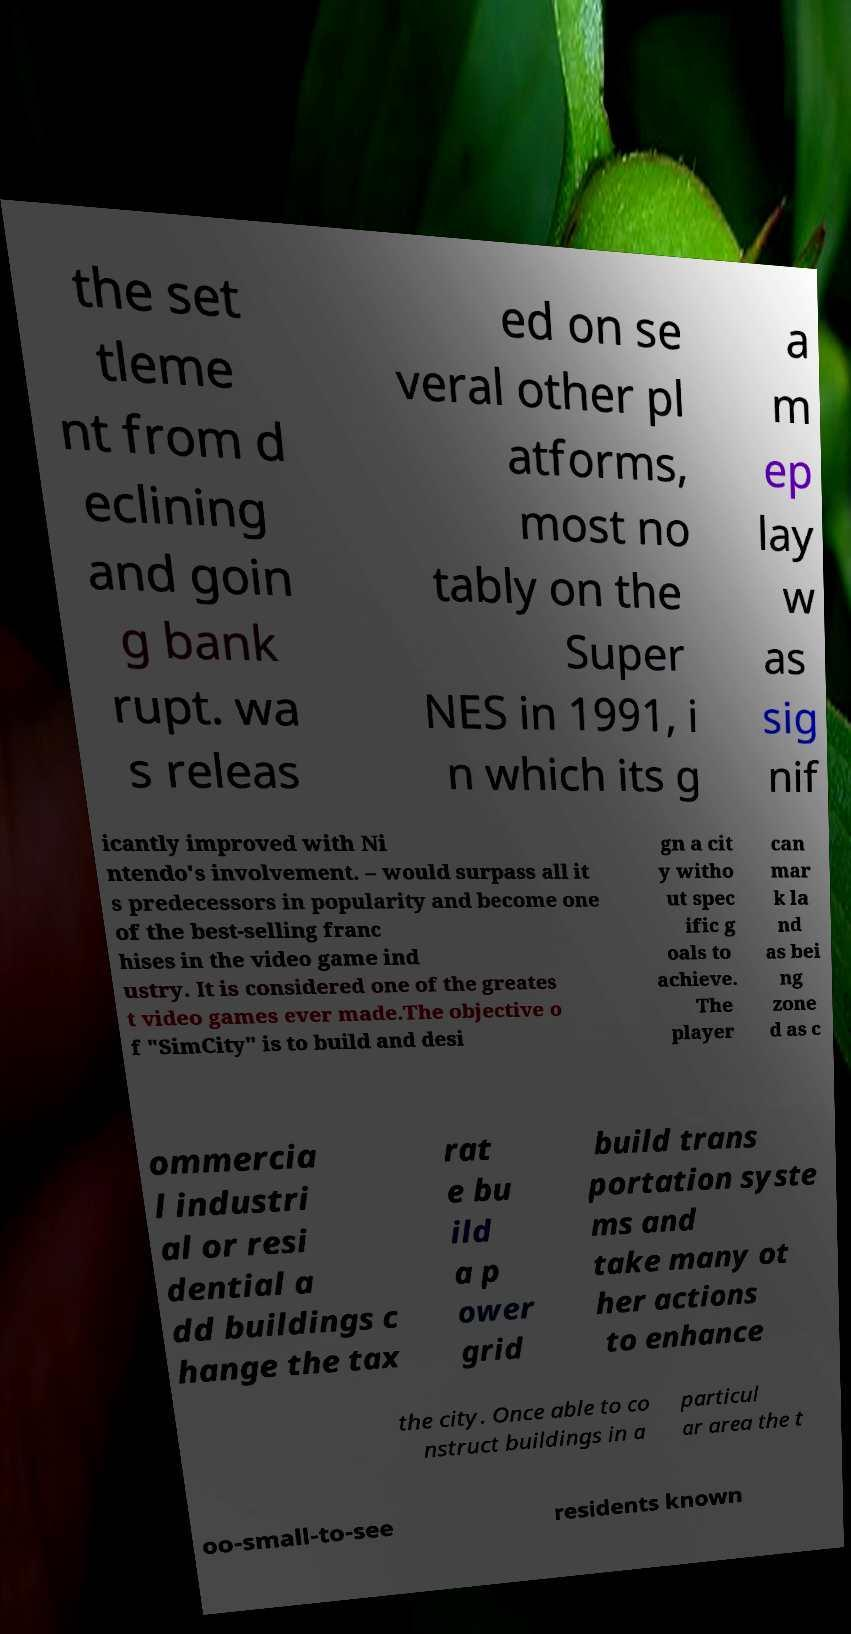Could you assist in decoding the text presented in this image and type it out clearly? the set tleme nt from d eclining and goin g bank rupt. wa s releas ed on se veral other pl atforms, most no tably on the Super NES in 1991, i n which its g a m ep lay w as sig nif icantly improved with Ni ntendo's involvement. – would surpass all it s predecessors in popularity and become one of the best-selling franc hises in the video game ind ustry. It is considered one of the greates t video games ever made.The objective o f "SimCity" is to build and desi gn a cit y witho ut spec ific g oals to achieve. The player can mar k la nd as bei ng zone d as c ommercia l industri al or resi dential a dd buildings c hange the tax rat e bu ild a p ower grid build trans portation syste ms and take many ot her actions to enhance the city. Once able to co nstruct buildings in a particul ar area the t oo-small-to-see residents known 